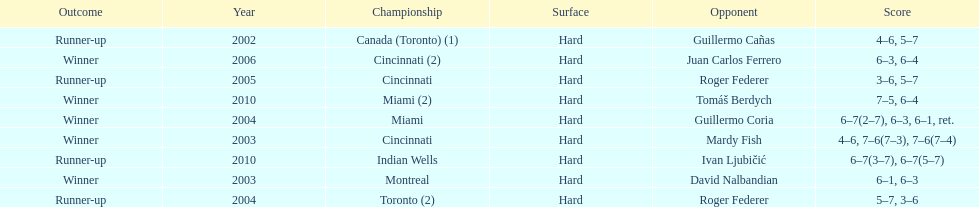How many consecutive years was there a hard surface at the championship? 9. 